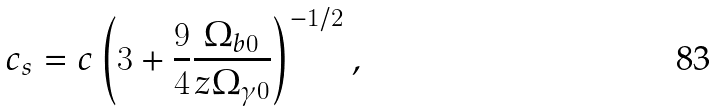<formula> <loc_0><loc_0><loc_500><loc_500>c _ { s } = c \left ( 3 + \frac { 9 } { 4 } \frac { \Omega _ { b 0 } } { z \Omega _ { \gamma 0 } } \right ) ^ { - 1 / 2 } ,</formula> 